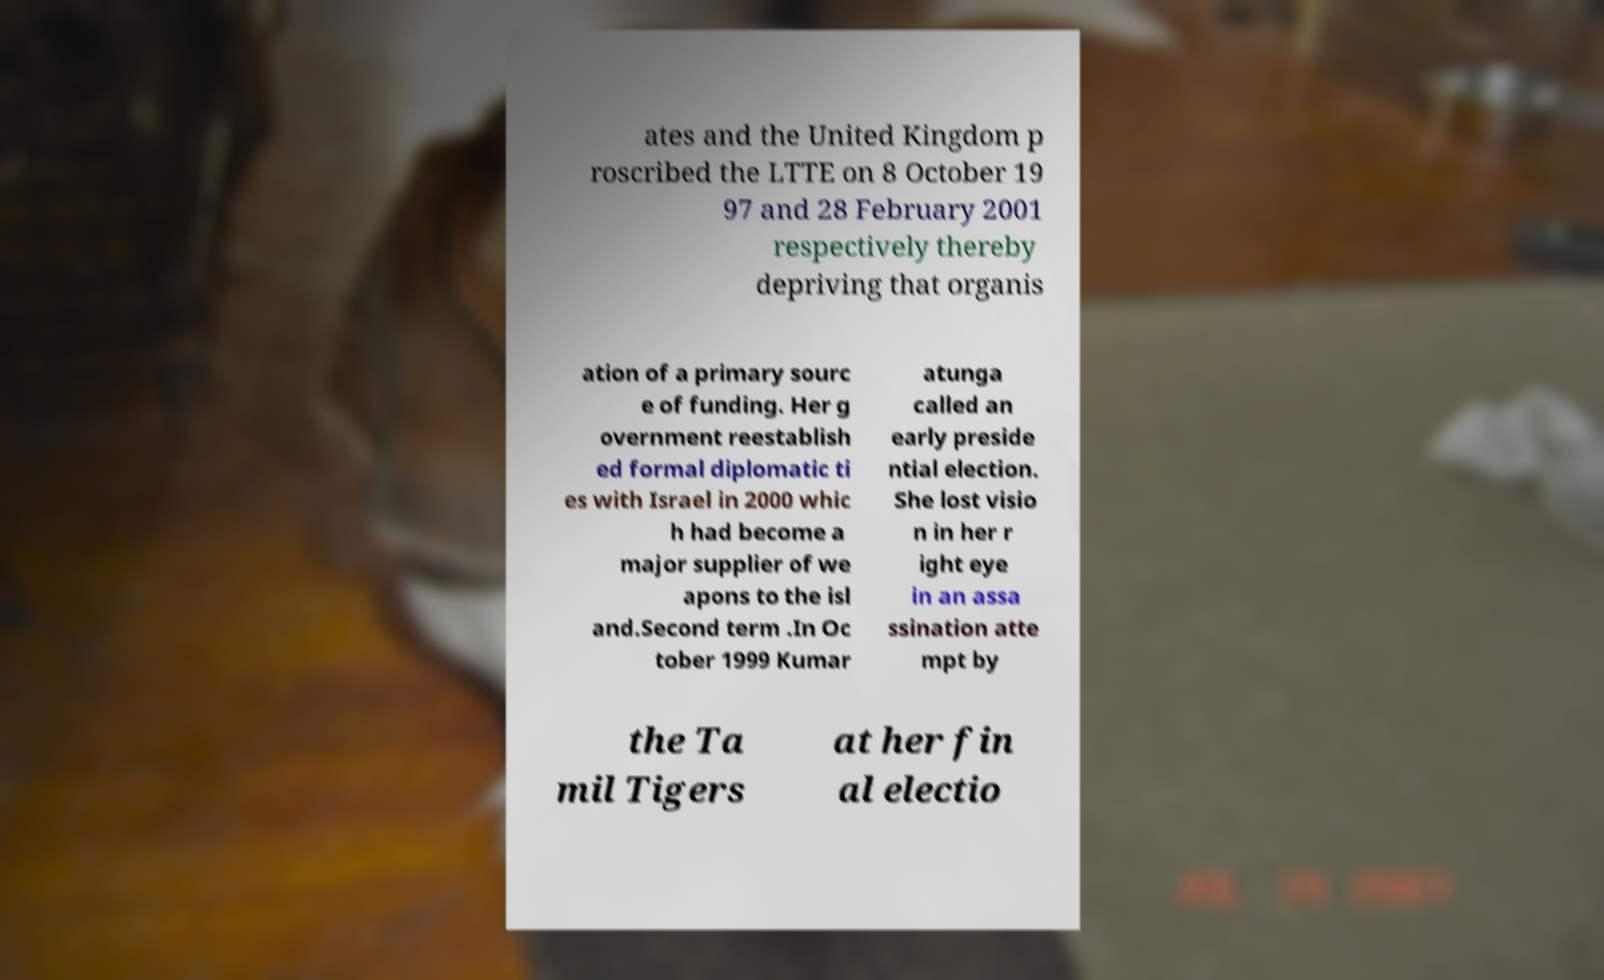Please identify and transcribe the text found in this image. ates and the United Kingdom p roscribed the LTTE on 8 October 19 97 and 28 February 2001 respectively thereby depriving that organis ation of a primary sourc e of funding. Her g overnment reestablish ed formal diplomatic ti es with Israel in 2000 whic h had become a major supplier of we apons to the isl and.Second term .In Oc tober 1999 Kumar atunga called an early preside ntial election. She lost visio n in her r ight eye in an assa ssination atte mpt by the Ta mil Tigers at her fin al electio 